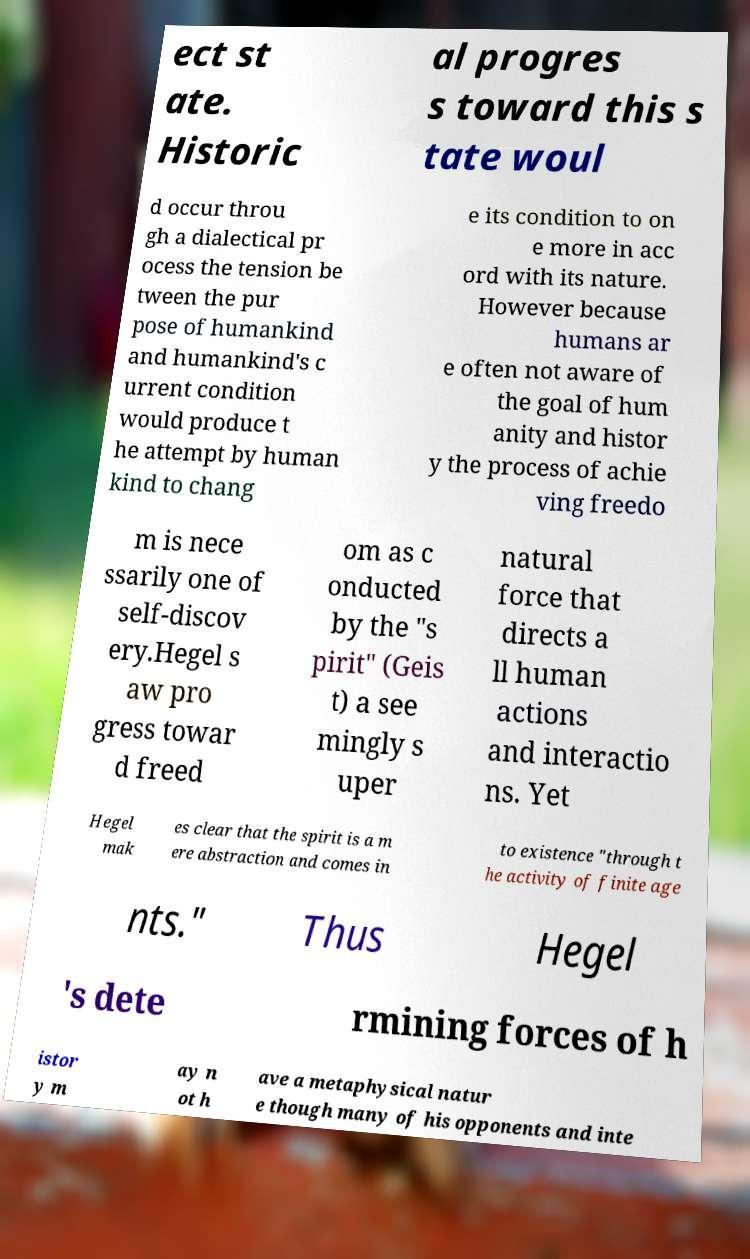What messages or text are displayed in this image? I need them in a readable, typed format. ect st ate. Historic al progres s toward this s tate woul d occur throu gh a dialectical pr ocess the tension be tween the pur pose of humankind and humankind's c urrent condition would produce t he attempt by human kind to chang e its condition to on e more in acc ord with its nature. However because humans ar e often not aware of the goal of hum anity and histor y the process of achie ving freedo m is nece ssarily one of self-discov ery.Hegel s aw pro gress towar d freed om as c onducted by the "s pirit" (Geis t) a see mingly s uper natural force that directs a ll human actions and interactio ns. Yet Hegel mak es clear that the spirit is a m ere abstraction and comes in to existence "through t he activity of finite age nts." Thus Hegel 's dete rmining forces of h istor y m ay n ot h ave a metaphysical natur e though many of his opponents and inte 